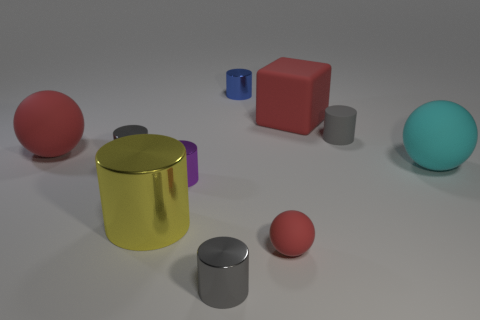Subtract all yellow blocks. How many gray cylinders are left? 3 Subtract 3 cylinders. How many cylinders are left? 3 Subtract all purple cylinders. How many cylinders are left? 5 Subtract all big cylinders. How many cylinders are left? 5 Subtract all red cylinders. Subtract all red spheres. How many cylinders are left? 6 Subtract all balls. How many objects are left? 7 Subtract 0 green cylinders. How many objects are left? 10 Subtract all large spheres. Subtract all tiny purple metallic things. How many objects are left? 7 Add 9 big yellow shiny cylinders. How many big yellow shiny cylinders are left? 10 Add 8 small purple things. How many small purple things exist? 9 